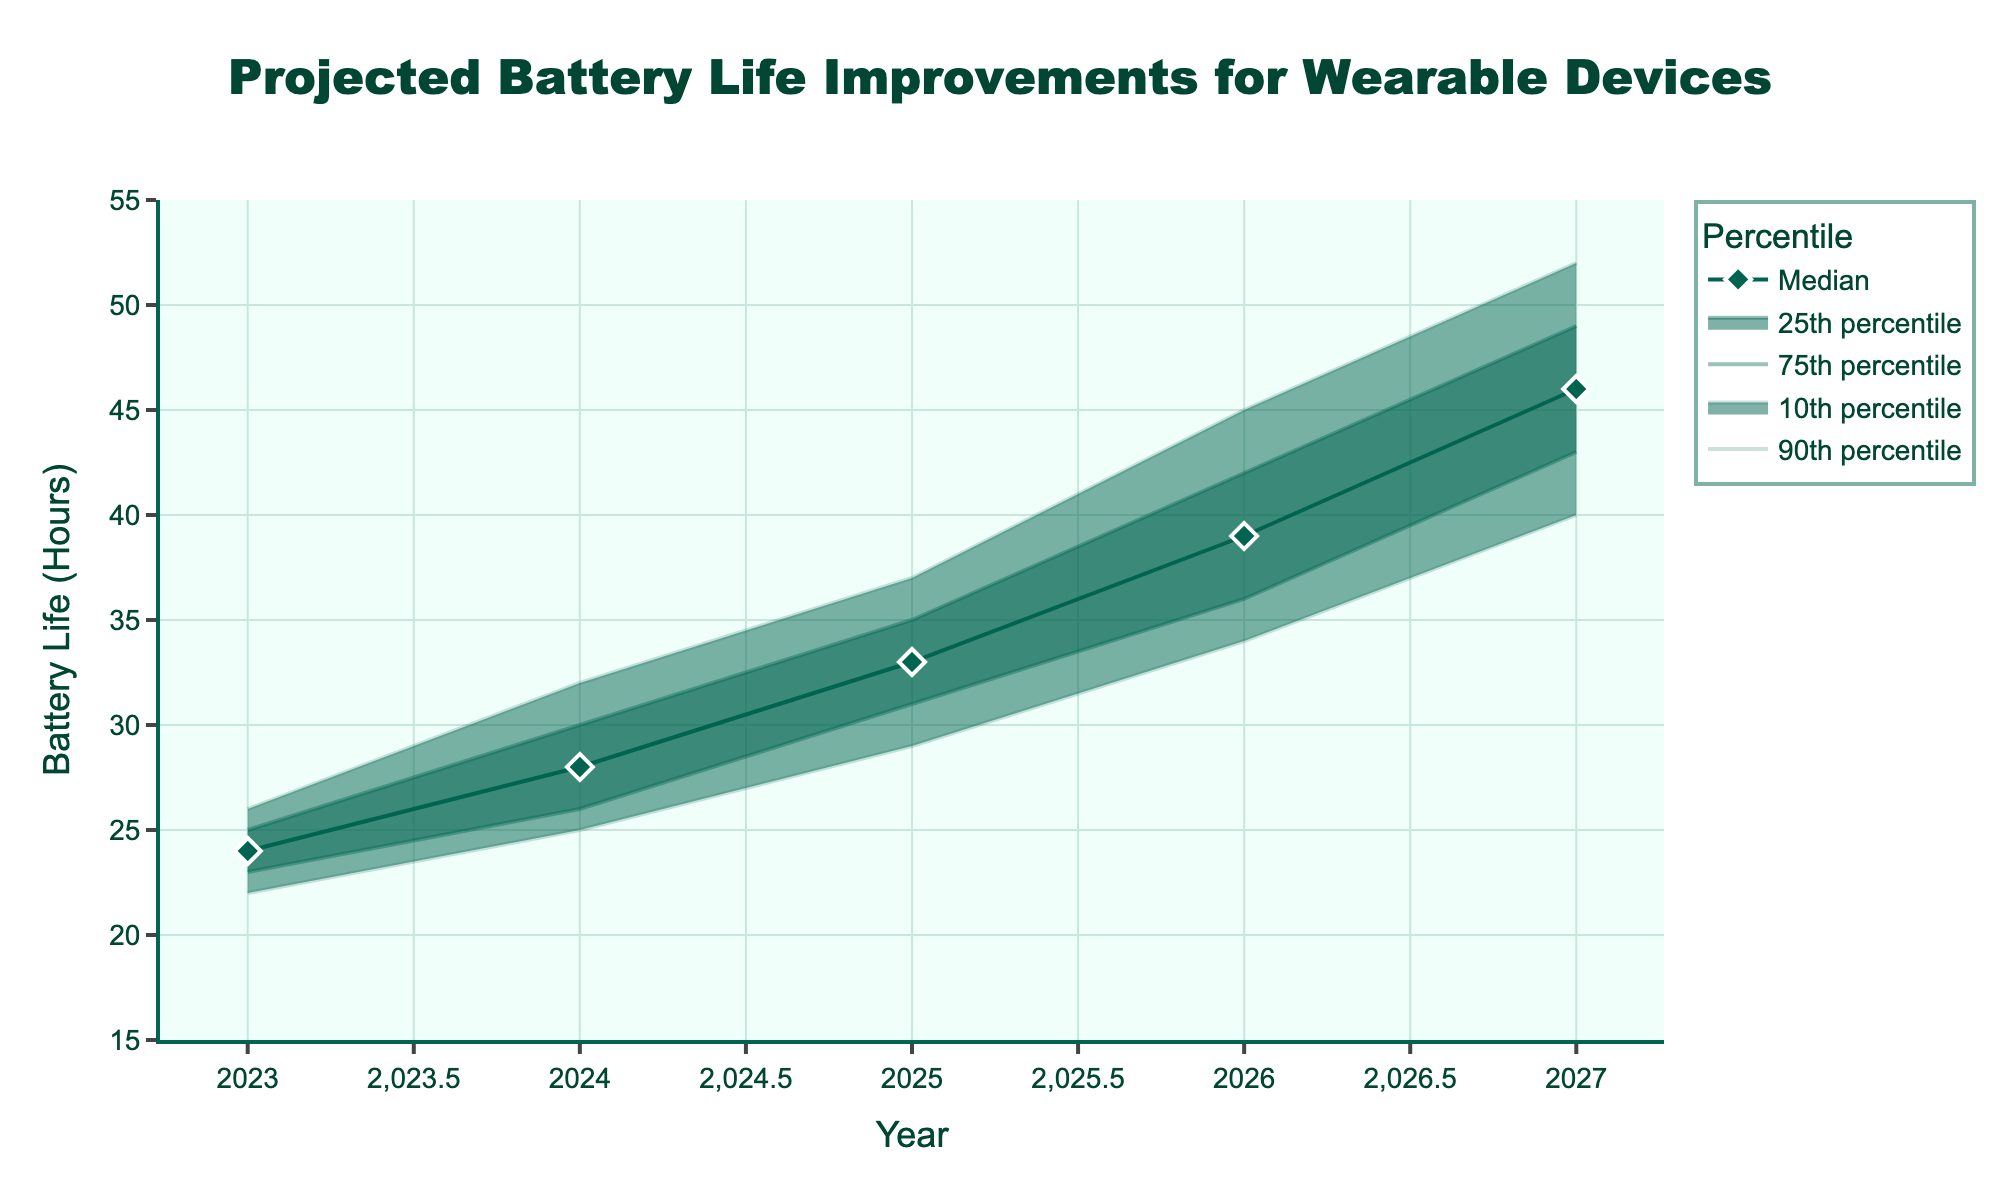What is the title of the chart? The title of the chart is prominently displayed at the top, centered and detailed in a larger font size for emphasis.
Answer: Projected Battery Life Improvements for Wearable Devices What is the median projected battery life in 2024? The median projected battery life for any given year can be directly read off the plot where the 'Median' line intersects the corresponding year on the x-axis. For the year 2024, this intersection occurs at 28 hours.
Answer: 28 hours How has the median projected battery life changed from 2023 to 2027? To find the change, subtract the median value in 2023 from the median value in 2027. The median in 2023 is 24 hours and in 2027 it is 46 hours. So, 46 - 24 = 22 hours.
Answer: 22 hours What is the range of battery life in 2026 between the 10th and 90th percentiles? The range is calculated by subtracting the lower bound (Lower10) from the upper bound (Upper90) for a specific year. In 2026, the Lower10 is 34 hours and the Upper90 is 45 hours, so the range is 45 - 34 = 11 hours.
Answer: 11 hours Between which years does the upper 90th percentile reach above 50 hours? Observing the intersection of the Upper90 line with the y-axis, we see that in 2027, it crosses above 50 hours. Hence, the range is specifically from 2026 to 2027 only.
Answer: 2027 Which year has the smallest range between the 25th and 75th percentiles? For each year, subtract the Lower25 value from the Upper75 value. The smallest difference indicates the smallest range. For 2023: 25-23=2, for 2024: 30-26=4, for 2025: 35-31=4, for 2026: 42-36=6, and for 2027: 49-43=6. The smallest range is in 2023 with a difference of 2 hours.
Answer: 2023 In which year do we see the highest projected median battery life? The highest projected median battery life can be observed at the tallest peak of the 'Median' line. The year corresponding to this peak's highest value is 2027, where the projected median battery life is 46 hours.
Answer: 2027 What is the expected increase in upper 75th percentile from 2023 to 2025? The expected increase can be found by subtracting the Upper75 value in 2023 from the Upper75 value in 2025. For 2023, it's 25 hours, and for 2025, it's 35 hours. So, 35 - 25 = 10 hours.
Answer: 10 hours For which percentiles is the trend line consistently rising from 2023 to 2027? Carefully observing the trend lines, the 'Median', 'Upper75', and 'Upper90' lines consistently rise from 2023 to 2027, indicating a continuous increase in these percentiles.
Answer: Median, Upper75, Upper90 How does the lower bound of battery life projections (10th percentile) change over the years? Looking at the Lower10 trend line across the years, we observe a steady increase from 22 hours in 2023 to 40 hours in 2027, demonstrating a consistent improvement in the lower bound projections.
Answer: Steadily increases from 22 hours to 40 hours 